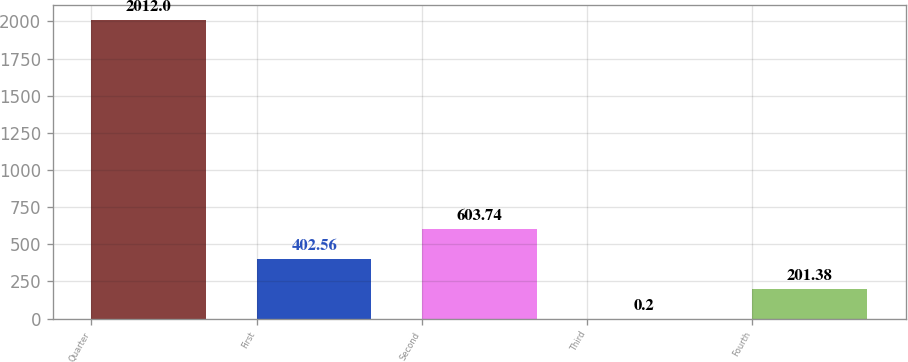Convert chart. <chart><loc_0><loc_0><loc_500><loc_500><bar_chart><fcel>Quarter<fcel>First<fcel>Second<fcel>Third<fcel>Fourth<nl><fcel>2012<fcel>402.56<fcel>603.74<fcel>0.2<fcel>201.38<nl></chart> 